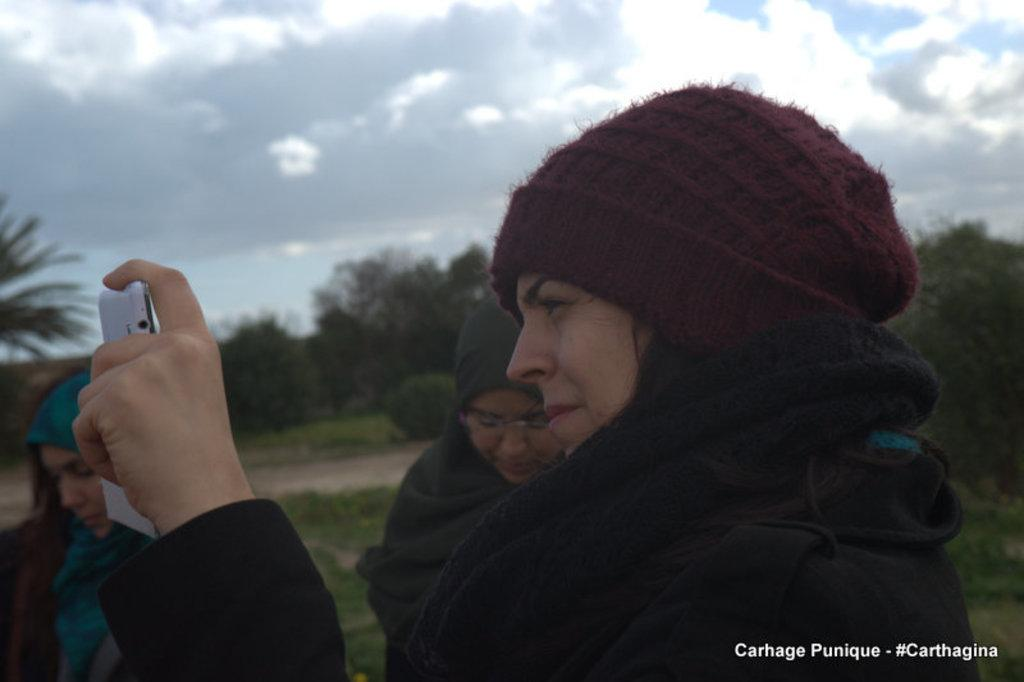How many people are in the image? There is a group of people in the image. What type of clothing are the people wearing? The people are wearing jackets and caps. Can you describe the woman in the image? The woman is holding a phone in her hand. What is the weather like in the image? The sky is cloudy in the background. What can be seen in the distance in the image? There are trees visible in the background. What is the result of the addition problem written on the ground in the image? There is no addition problem written on the ground in the image. 